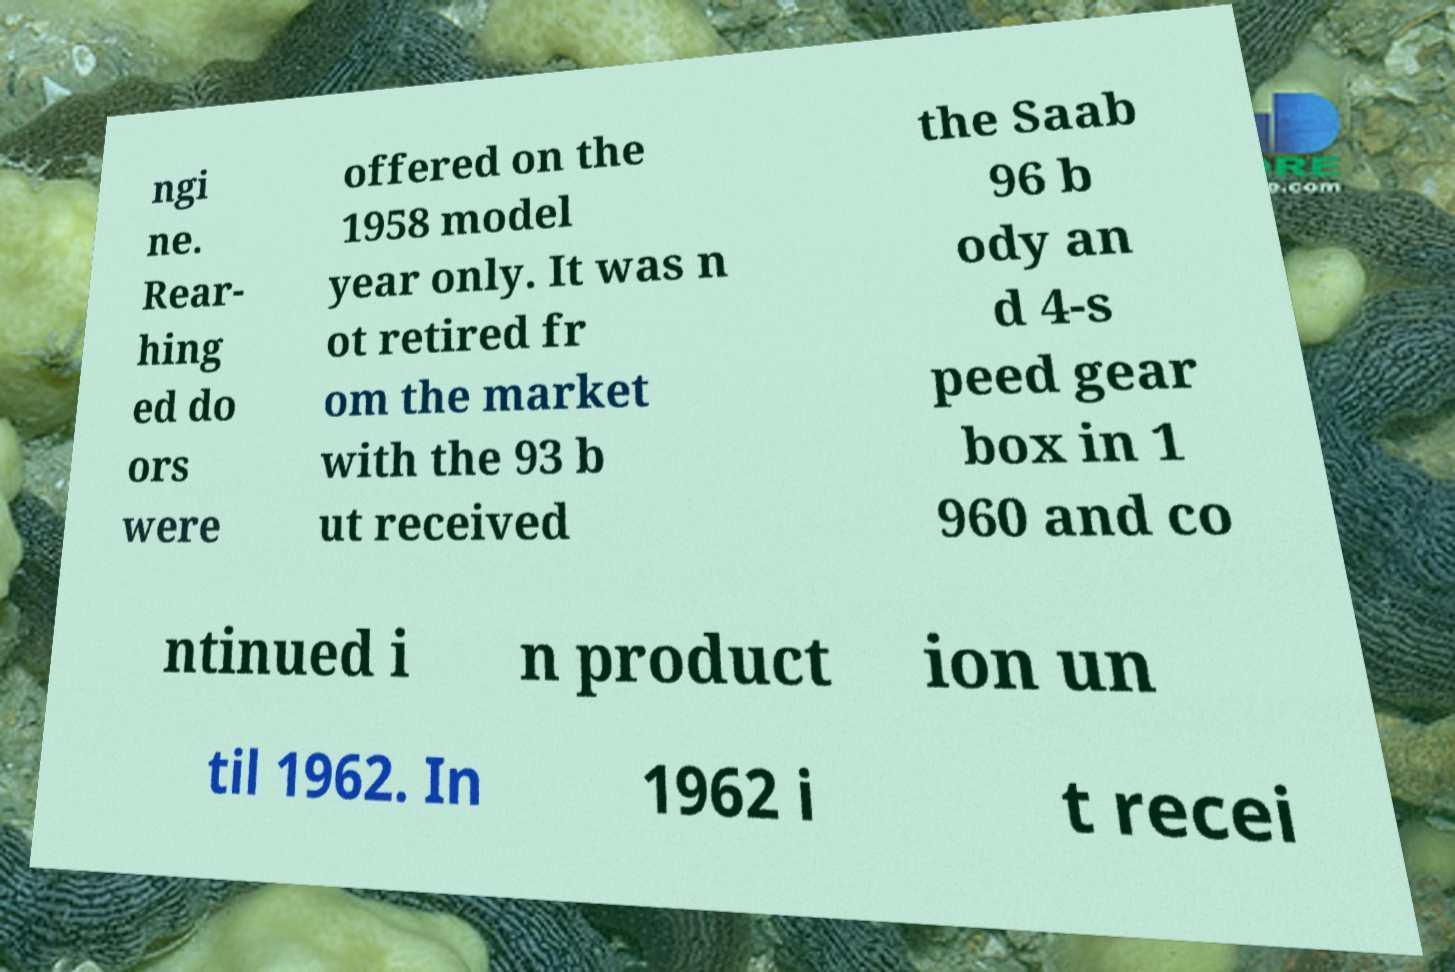What messages or text are displayed in this image? I need them in a readable, typed format. ngi ne. Rear- hing ed do ors were offered on the 1958 model year only. It was n ot retired fr om the market with the 93 b ut received the Saab 96 b ody an d 4-s peed gear box in 1 960 and co ntinued i n product ion un til 1962. In 1962 i t recei 